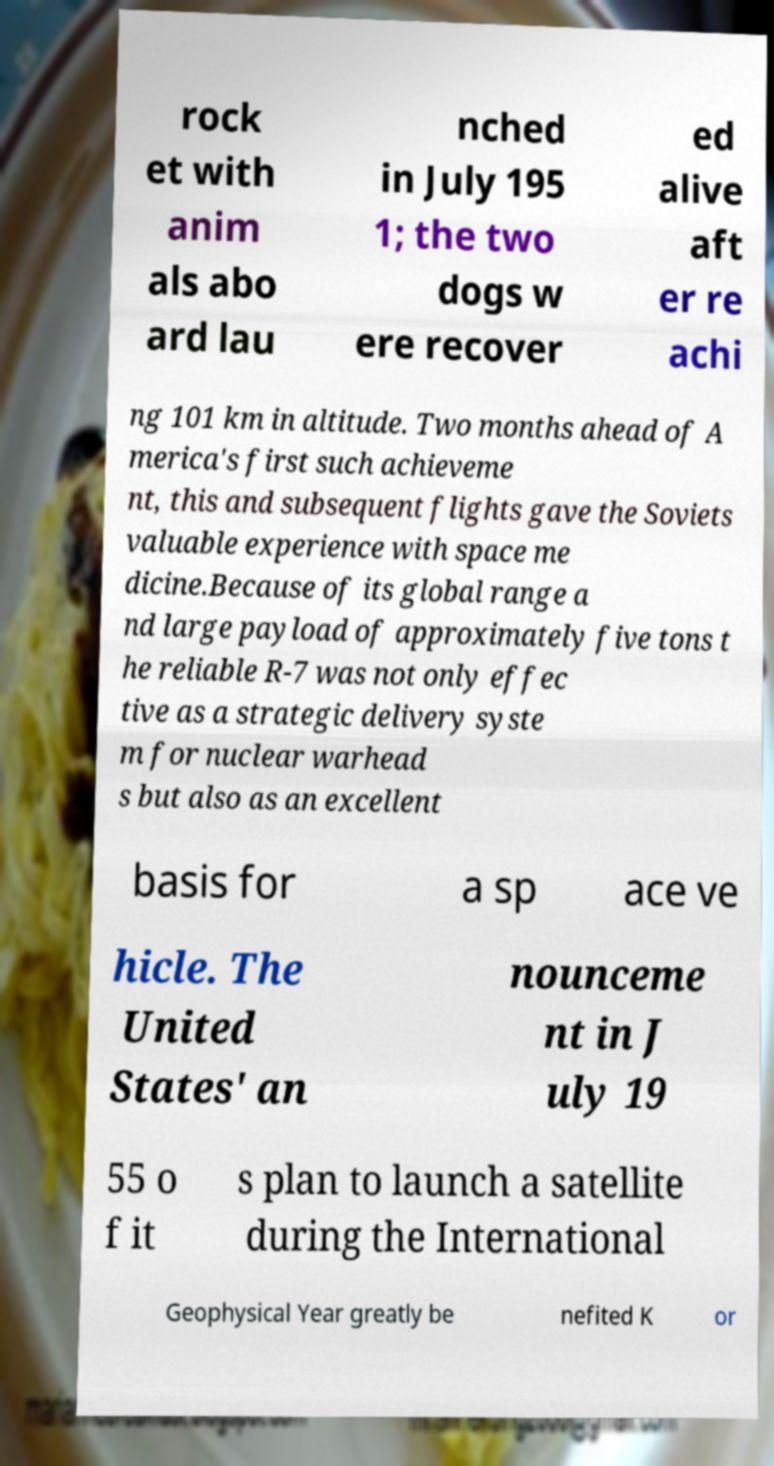There's text embedded in this image that I need extracted. Can you transcribe it verbatim? rock et with anim als abo ard lau nched in July 195 1; the two dogs w ere recover ed alive aft er re achi ng 101 km in altitude. Two months ahead of A merica's first such achieveme nt, this and subsequent flights gave the Soviets valuable experience with space me dicine.Because of its global range a nd large payload of approximately five tons t he reliable R-7 was not only effec tive as a strategic delivery syste m for nuclear warhead s but also as an excellent basis for a sp ace ve hicle. The United States' an nounceme nt in J uly 19 55 o f it s plan to launch a satellite during the International Geophysical Year greatly be nefited K or 